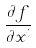Convert formula to latex. <formula><loc_0><loc_0><loc_500><loc_500>\frac { \partial f } { \partial x ^ { i } }</formula> 